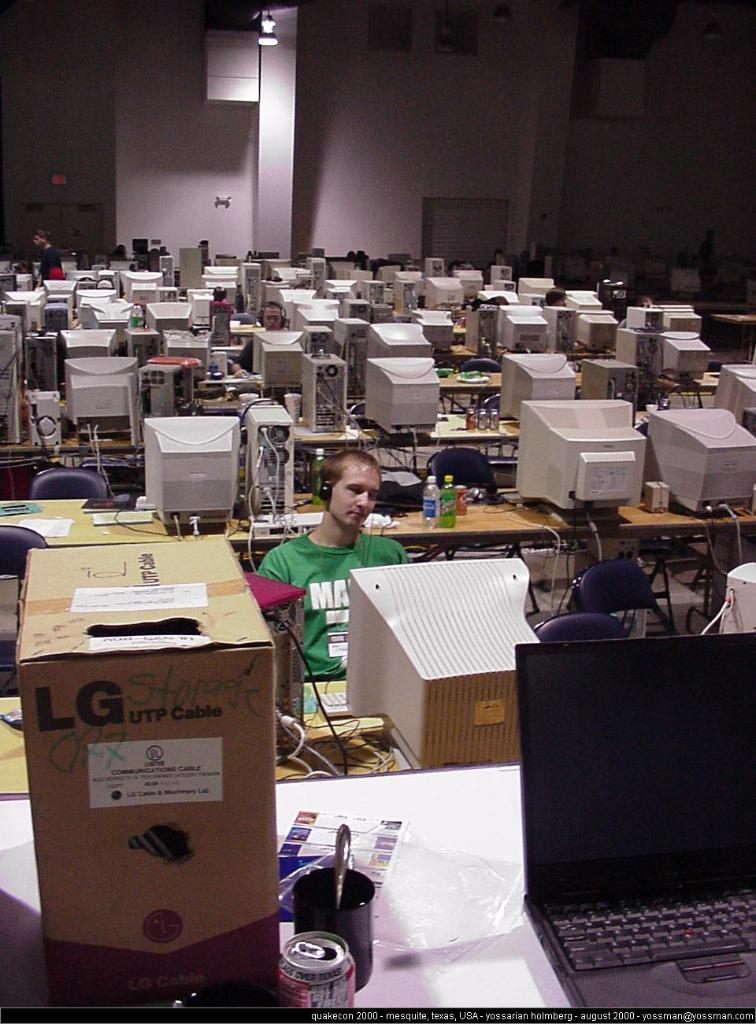<image>
Offer a succinct explanation of the picture presented. A cardboard box contains a LG UTP cable. 